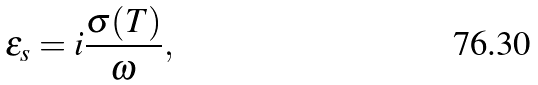Convert formula to latex. <formula><loc_0><loc_0><loc_500><loc_500>\varepsilon _ { s } = i \frac { \sigma ( T ) } { \omega } ,</formula> 